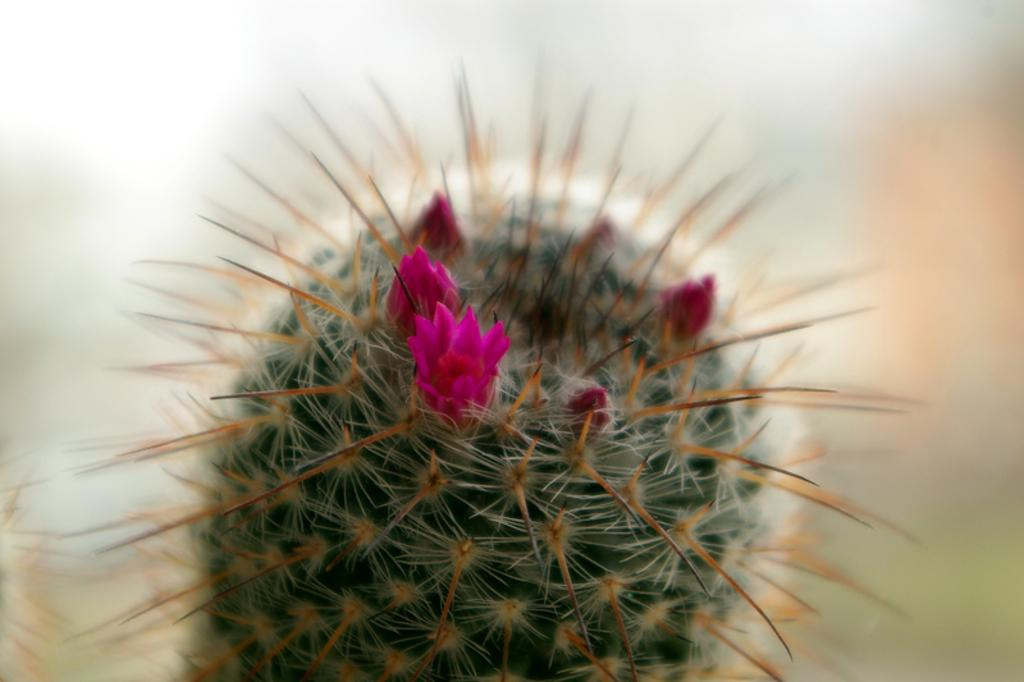What type of plant is in the foreground of the image? There is a desert plant in the foreground of the image. What other type of plant can be seen near the desert plant? There is a flower near the desert plant. Are there any unopened flowers near the desert plant? Yes, there are buds near the desert plant. What type of authority does the question have in the image? There is no question or authority present in the image; it features desert plants, a flower, and buds. 